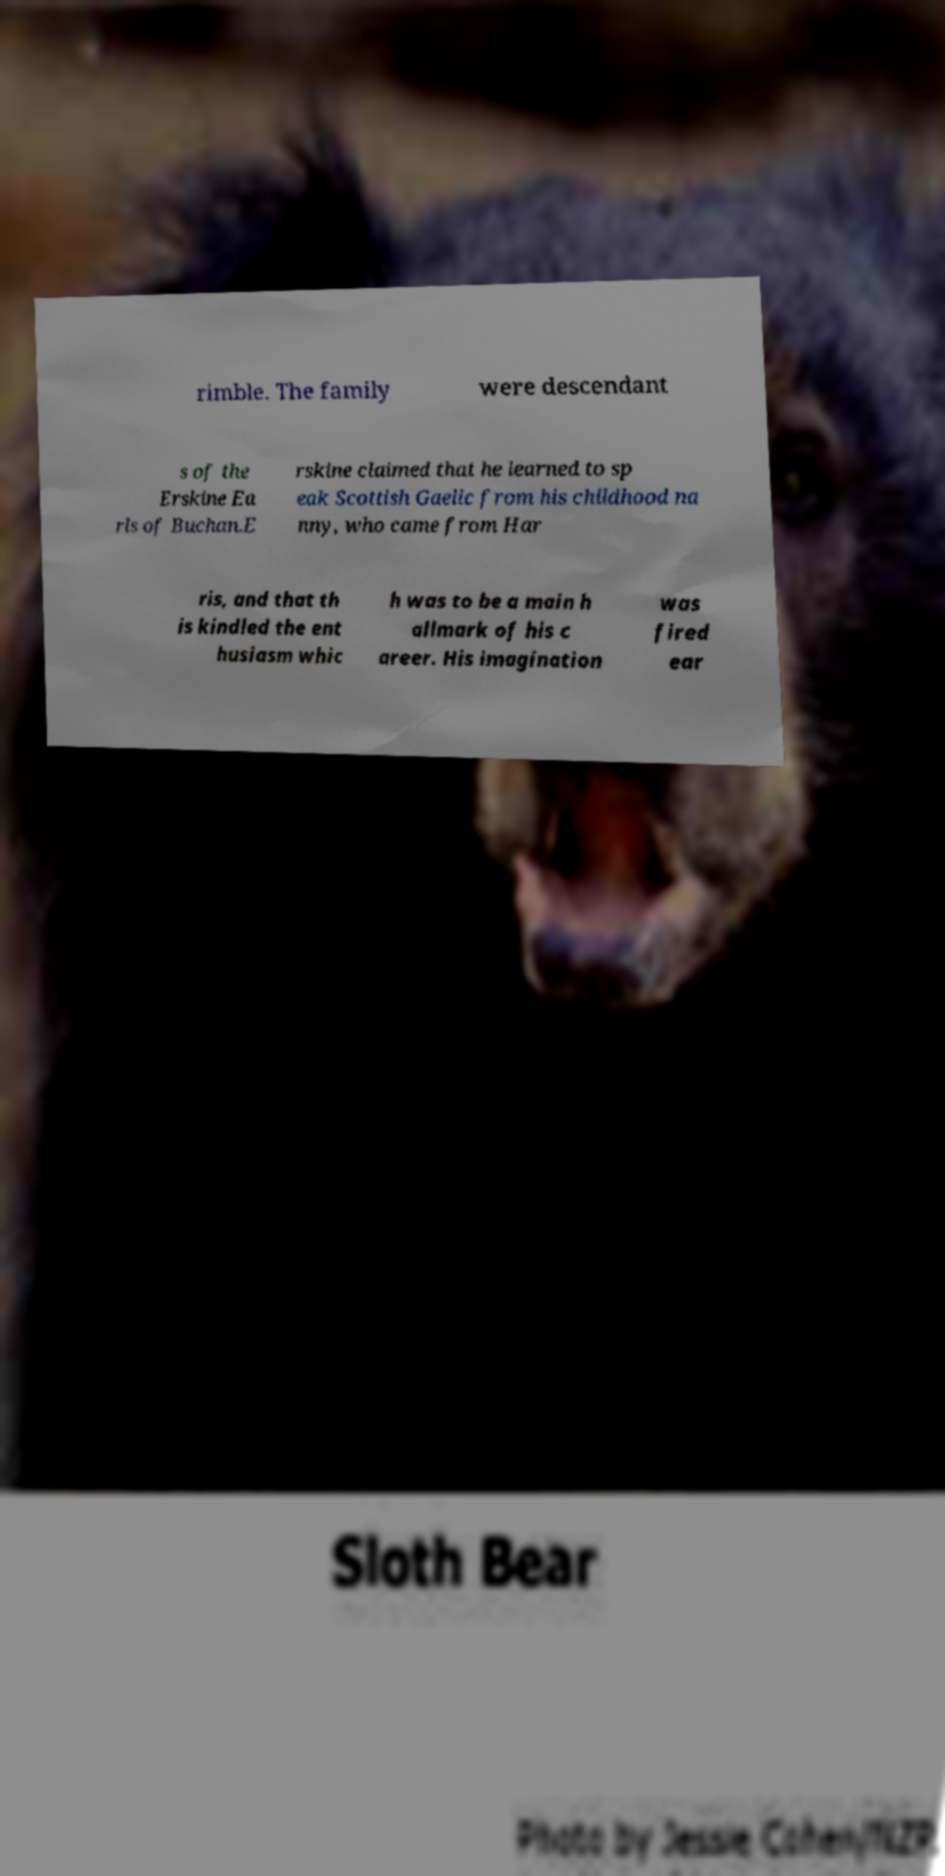Please read and relay the text visible in this image. What does it say? rimble. The family were descendant s of the Erskine Ea rls of Buchan.E rskine claimed that he learned to sp eak Scottish Gaelic from his childhood na nny, who came from Har ris, and that th is kindled the ent husiasm whic h was to be a main h allmark of his c areer. His imagination was fired ear 